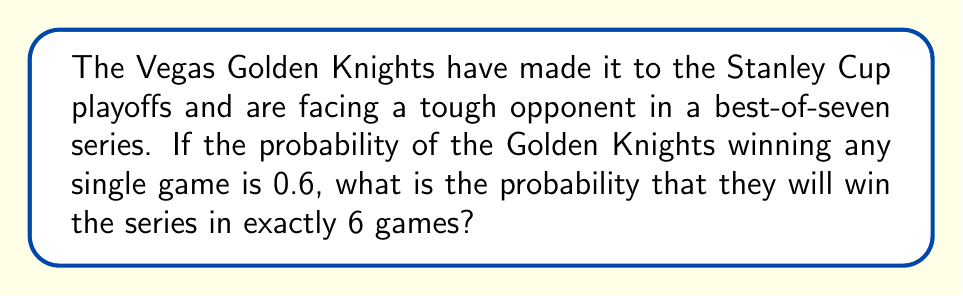Teach me how to tackle this problem. Let's approach this step-by-step:

1) For the Golden Knights to win in exactly 6 games, they need to win 4 games and lose 2 games out of the first 6 games.

2) The probability of winning a single game is 0.6, so the probability of losing a single game is 1 - 0.6 = 0.4.

3) We need to calculate the probability of any specific sequence of 4 wins and 2 losses in the first 6 games, then multiply by the number of possible ways this can happen.

4) The probability of a specific sequence of 4 wins and 2 losses is:

   $$(0.6)^4 \cdot (0.4)^2 = 0.0207360$$

5) Now, we need to calculate how many ways we can arrange 4 wins and 2 losses in 6 games. This is a combination problem:

   $$\binom{6}{4} = \frac{6!}{4!(6-4)!} = \frac{6!}{4!2!} = 15$$

6) Therefore, the probability of winning in exactly 6 games is:

   $$15 \cdot (0.6)^4 \cdot (0.4)^2 = 15 \cdot 0.0207360 = 0.3110400$$
Answer: $0.3110400$ or approximately $31.104\%$ 